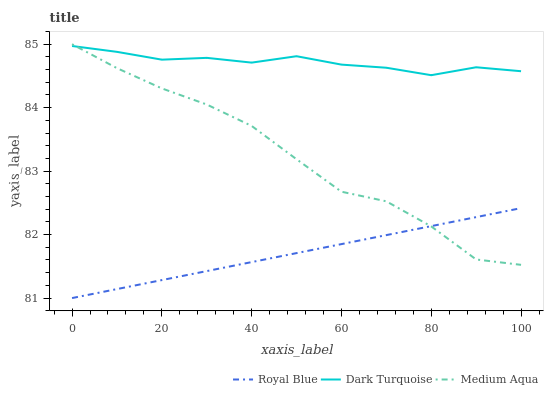Does Medium Aqua have the minimum area under the curve?
Answer yes or no. No. Does Medium Aqua have the maximum area under the curve?
Answer yes or no. No. Is Dark Turquoise the smoothest?
Answer yes or no. No. Is Dark Turquoise the roughest?
Answer yes or no. No. Does Medium Aqua have the lowest value?
Answer yes or no. No. Does Dark Turquoise have the highest value?
Answer yes or no. No. Is Royal Blue less than Dark Turquoise?
Answer yes or no. Yes. Is Dark Turquoise greater than Royal Blue?
Answer yes or no. Yes. Does Royal Blue intersect Dark Turquoise?
Answer yes or no. No. 